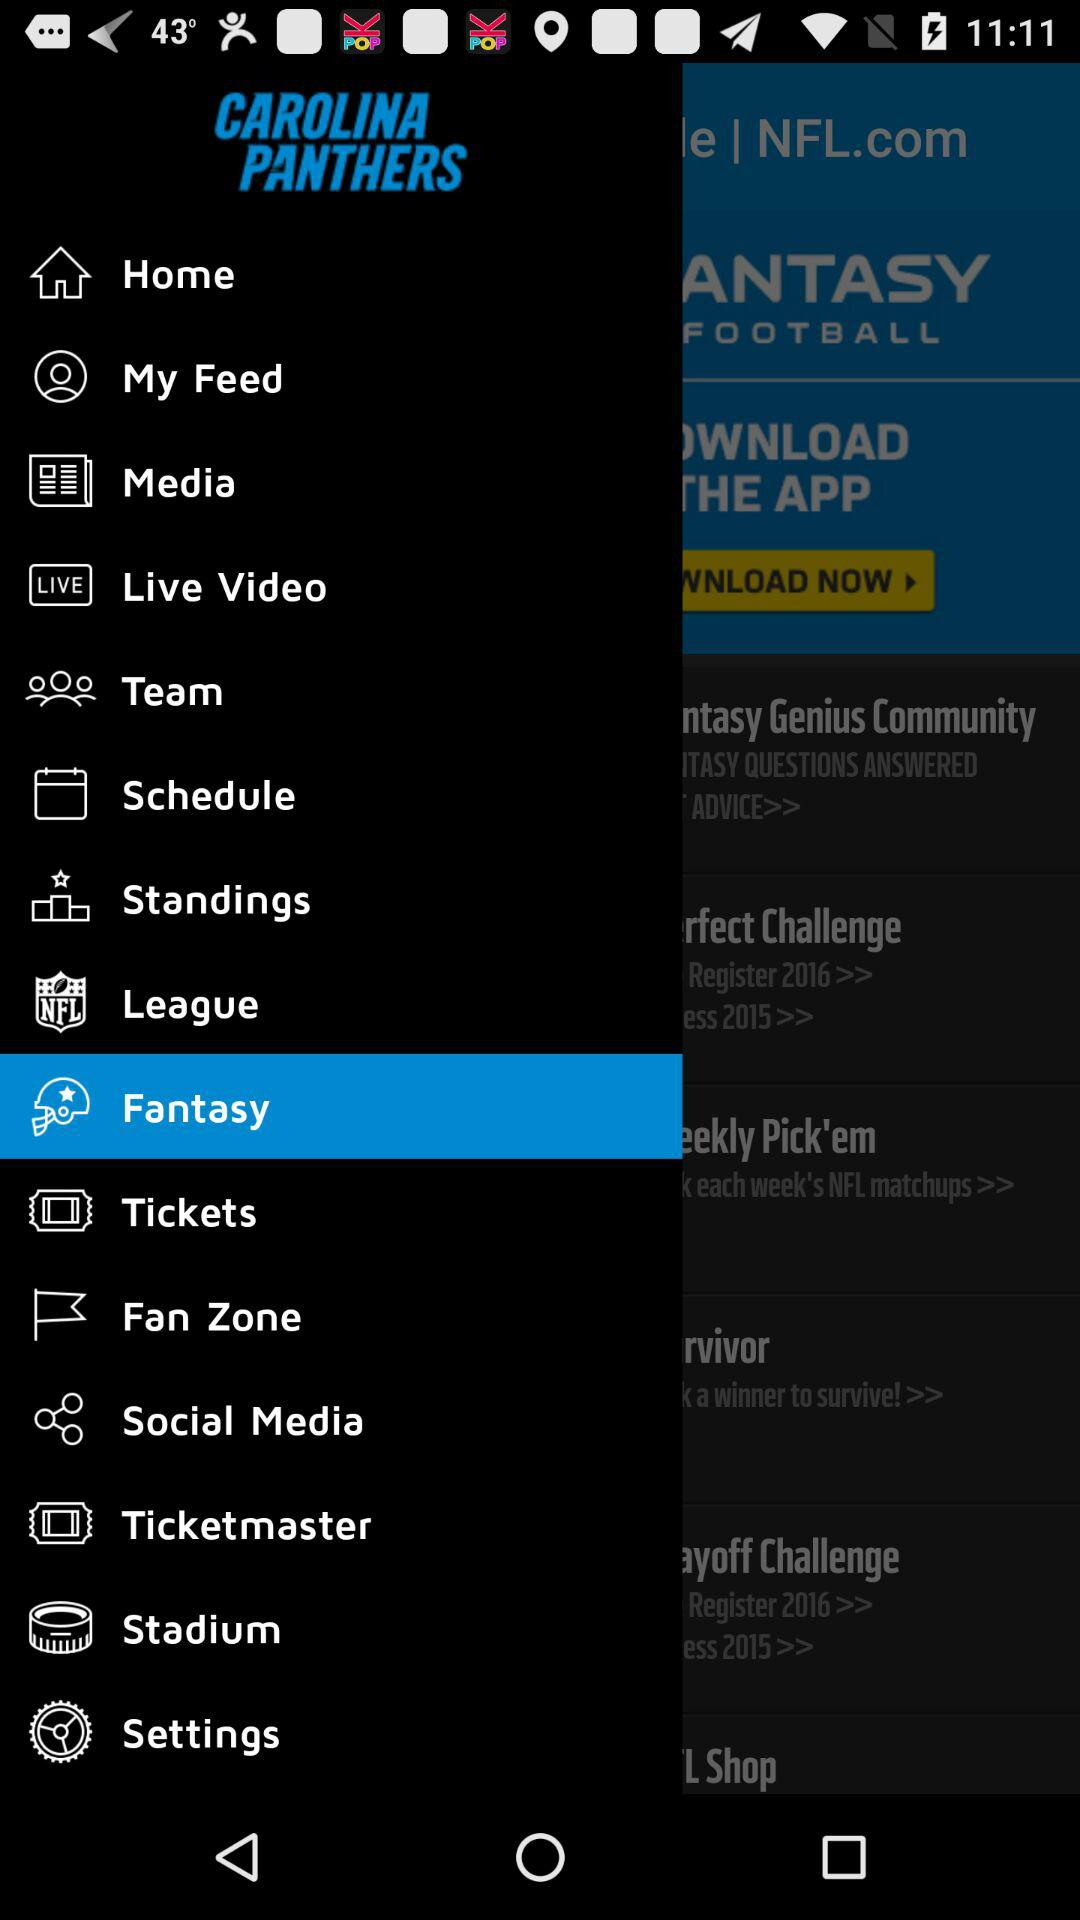Which item is selected? The selected item is "Fantasy". 